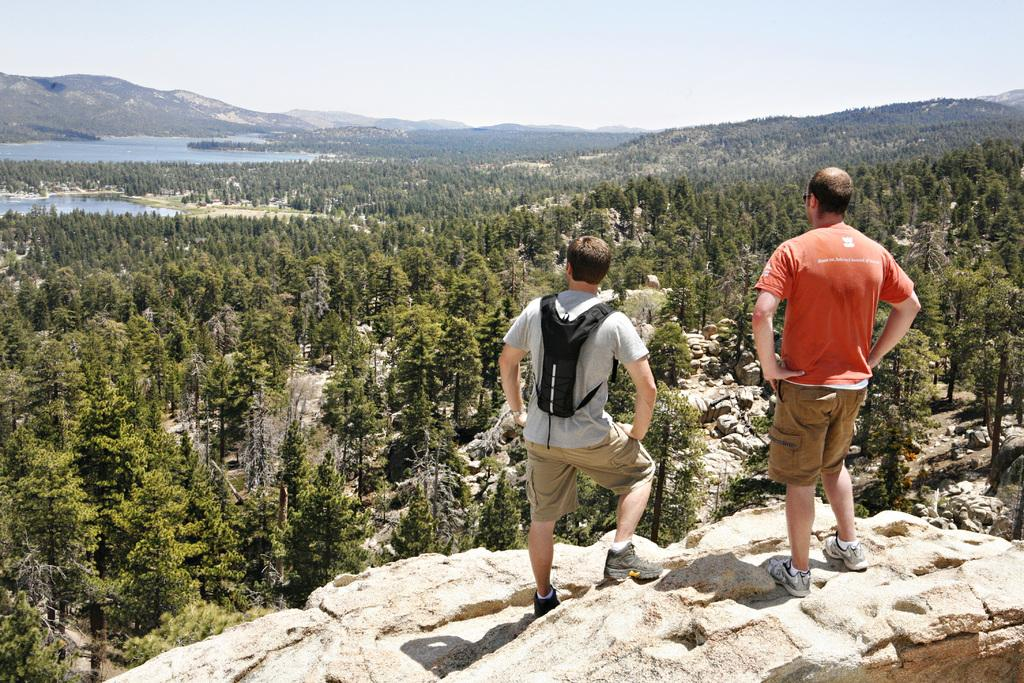How many people are in the image? There are two men in the image. What are the men standing on? The men are standing on a stone. What type of vegetation is present in the image? There are trees in the image. What geographical feature can be seen in the background? There is a mountain in the image. What is the condition of the sky in the image? The sky is clear in the image. What type of flowers are growing on the mountain in the image? There are no flowers visible on the mountain in the image. What unit of measurement is used to determine the height of the men in the image? There is no information provided about the height of the men or any unit of measurement used in the image. 